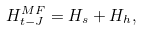<formula> <loc_0><loc_0><loc_500><loc_500>H _ { t - J } ^ { M F } = H _ { s } + H _ { h } ,</formula> 